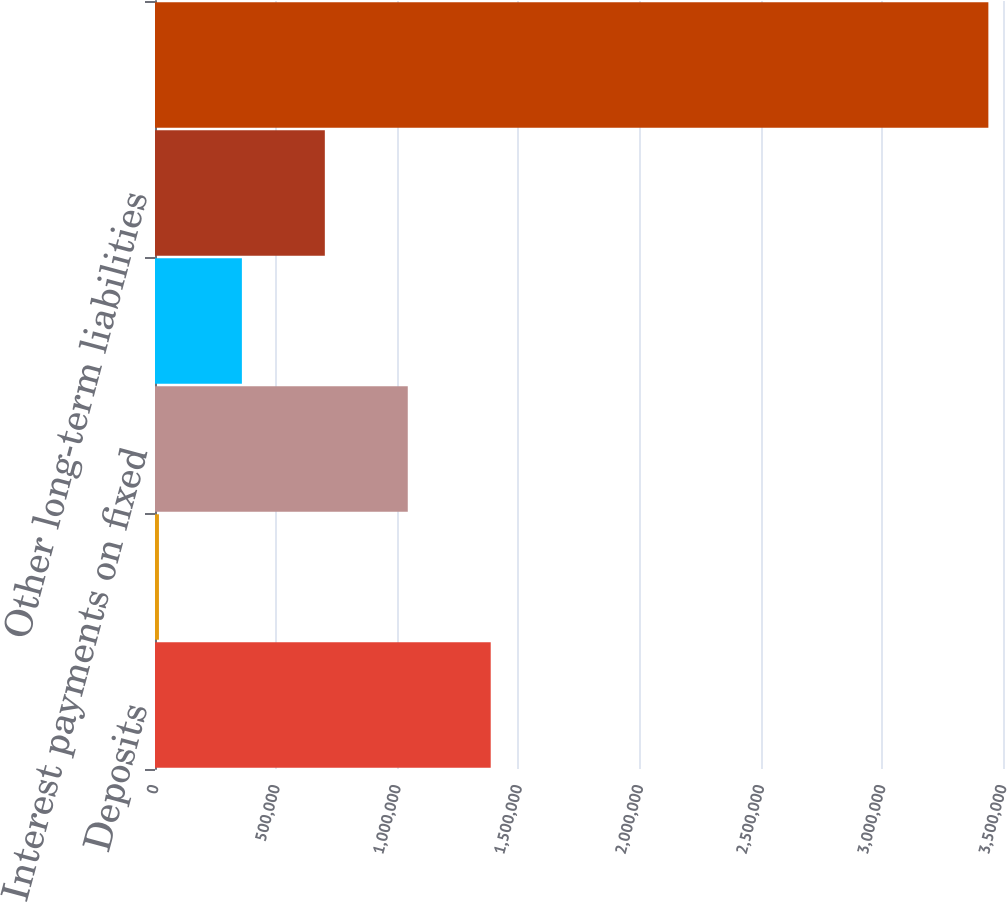<chart> <loc_0><loc_0><loc_500><loc_500><bar_chart><fcel>Deposits<fcel>Operating leases<fcel>Interest payments on fixed<fcel>Purchase obligations (2)<fcel>Other long-term liabilities<fcel>Total contractual obligations<nl><fcel>1.38561e+06<fcel>16281<fcel>1.04328e+06<fcel>358613<fcel>700946<fcel>3.4396e+06<nl></chart> 